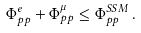<formula> <loc_0><loc_0><loc_500><loc_500>\Phi ^ { e } _ { p p } + \Phi ^ { \mu } _ { p p } \leq \Phi _ { p p } ^ { S S M } \, .</formula> 